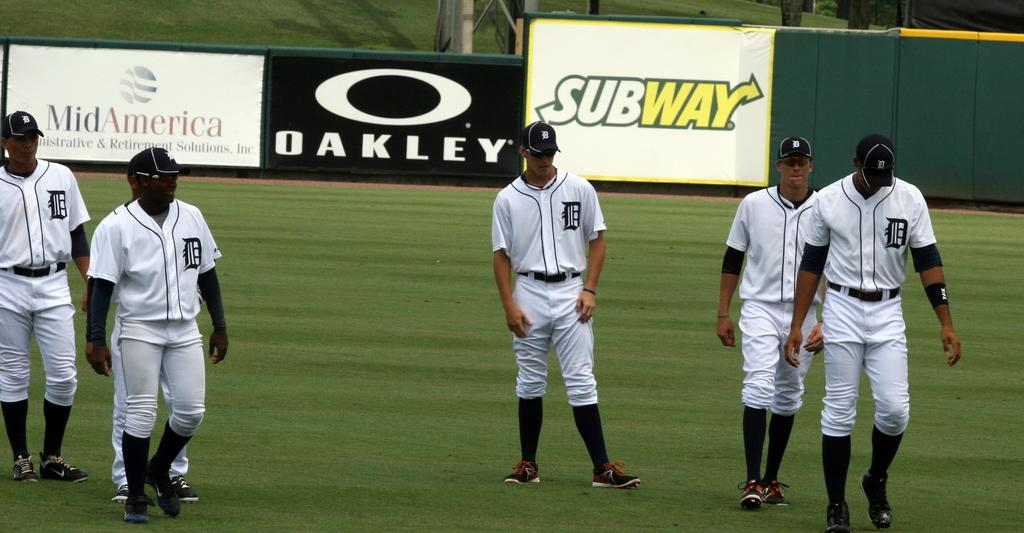<image>
Provide a brief description of the given image. Among the sponsors with banners decorating the outfield walls are MidAmerica, Oakley and Subway. 